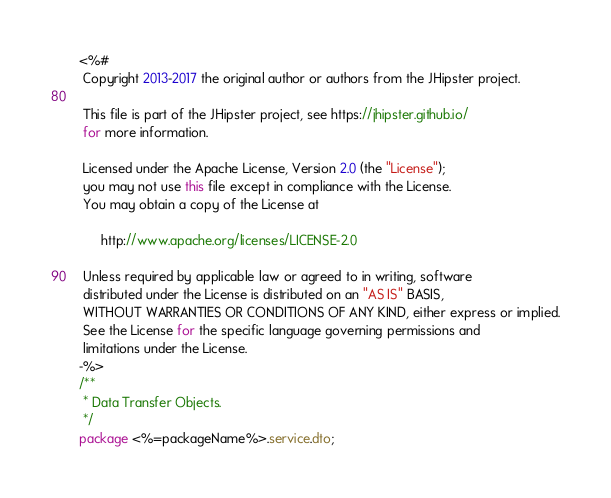Convert code to text. <code><loc_0><loc_0><loc_500><loc_500><_Java_><%#
 Copyright 2013-2017 the original author or authors from the JHipster project.

 This file is part of the JHipster project, see https://jhipster.github.io/
 for more information.

 Licensed under the Apache License, Version 2.0 (the "License");
 you may not use this file except in compliance with the License.
 You may obtain a copy of the License at

      http://www.apache.org/licenses/LICENSE-2.0

 Unless required by applicable law or agreed to in writing, software
 distributed under the License is distributed on an "AS IS" BASIS,
 WITHOUT WARRANTIES OR CONDITIONS OF ANY KIND, either express or implied.
 See the License for the specific language governing permissions and
 limitations under the License.
-%>
/**
 * Data Transfer Objects.
 */
package <%=packageName%>.service.dto;
</code> 